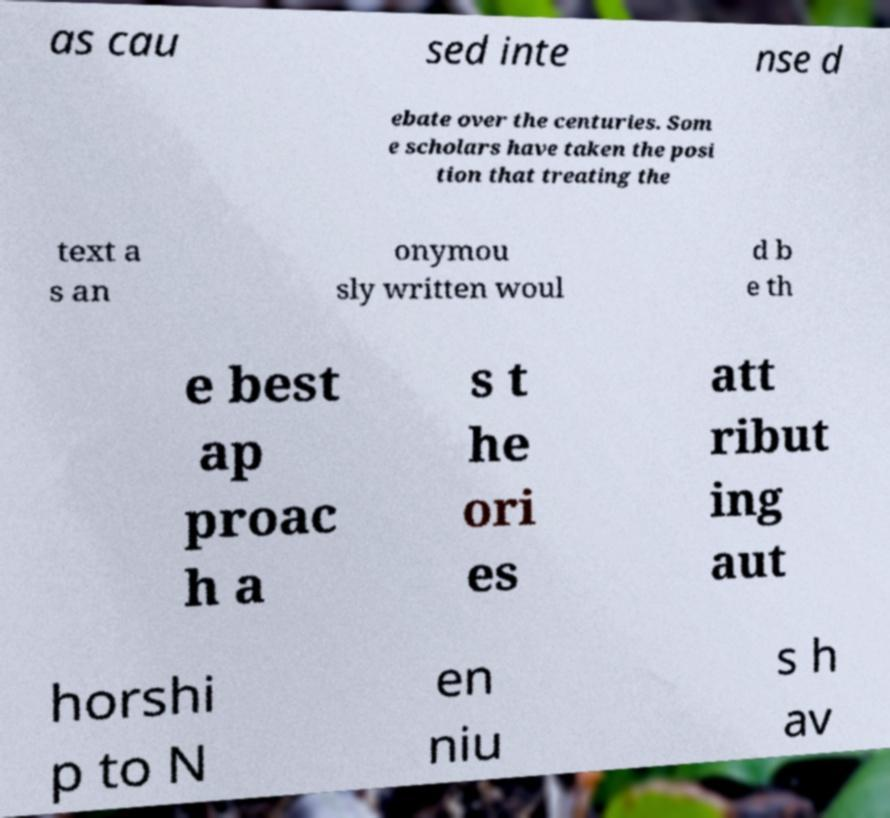For documentation purposes, I need the text within this image transcribed. Could you provide that? as cau sed inte nse d ebate over the centuries. Som e scholars have taken the posi tion that treating the text a s an onymou sly written woul d b e th e best ap proac h a s t he ori es att ribut ing aut horshi p to N en niu s h av 